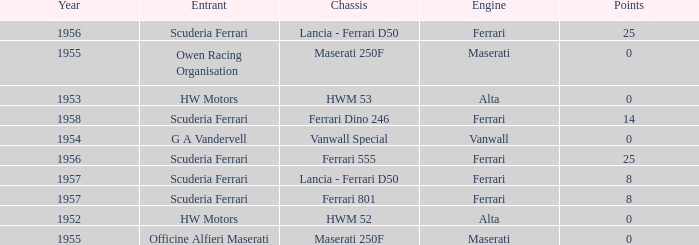What company made the chassis when Ferrari made the engine and there were 25 points? Ferrari 555, Lancia - Ferrari D50. 